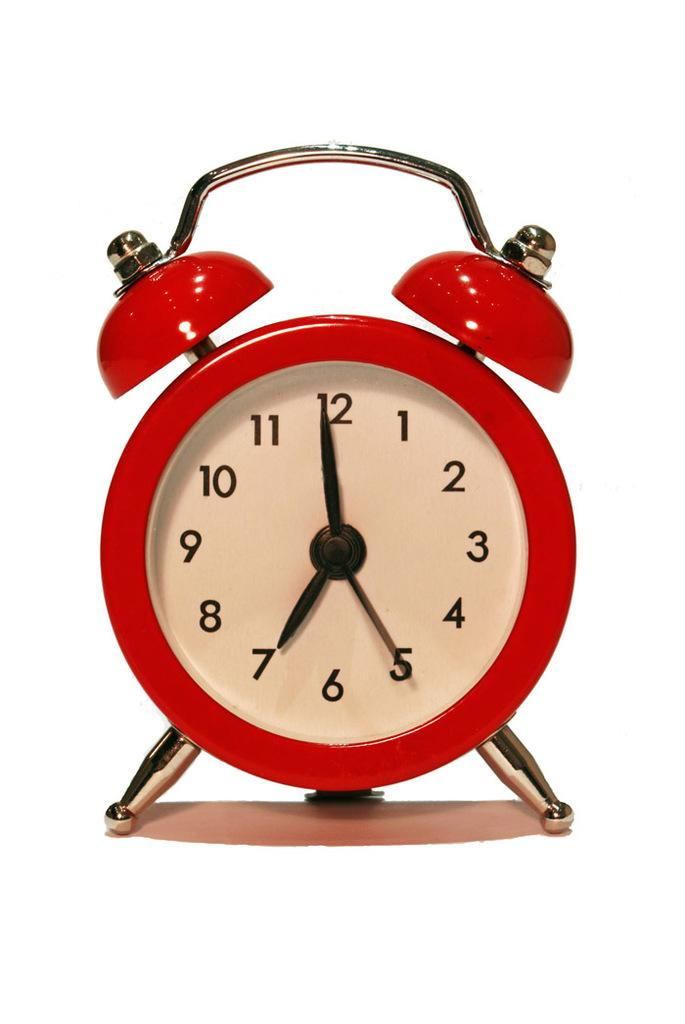<image>
Give a short and clear explanation of the subsequent image. A red alarm clocking showing the time 6:59. 